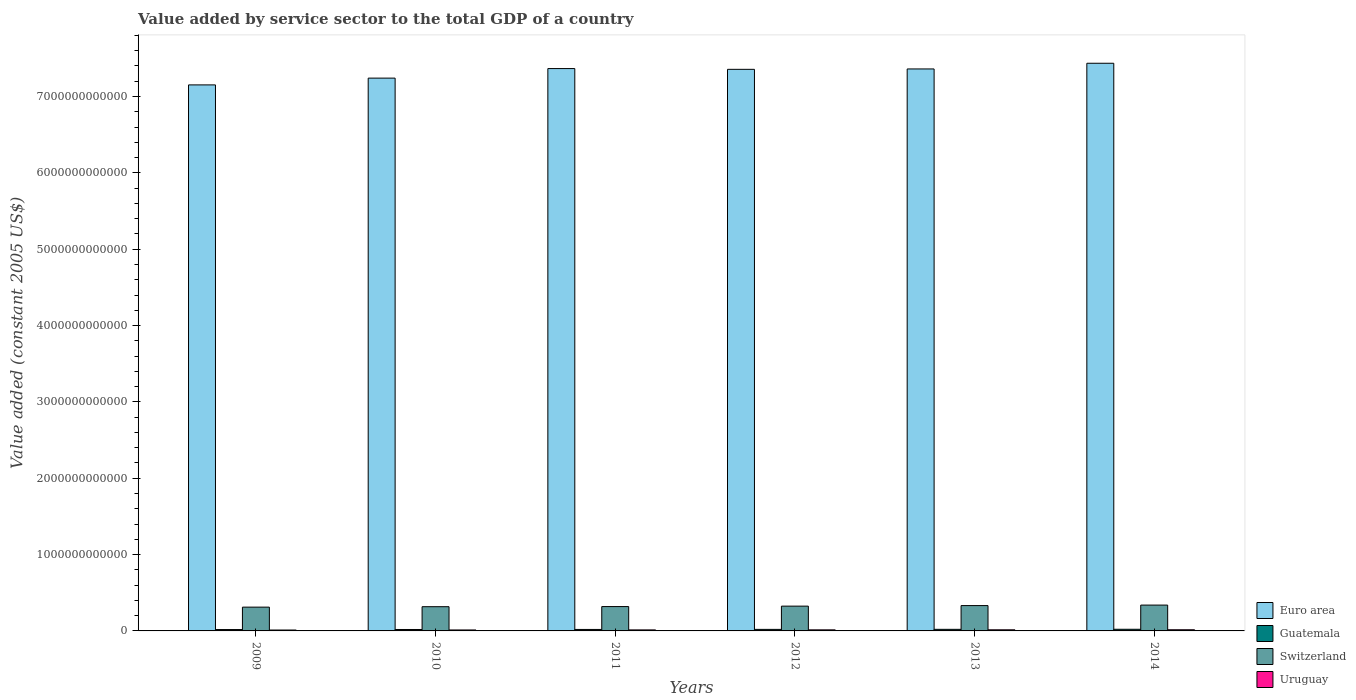Are the number of bars per tick equal to the number of legend labels?
Offer a terse response. Yes. Are the number of bars on each tick of the X-axis equal?
Provide a short and direct response. Yes. How many bars are there on the 5th tick from the left?
Your response must be concise. 4. What is the label of the 2nd group of bars from the left?
Keep it short and to the point. 2010. In how many cases, is the number of bars for a given year not equal to the number of legend labels?
Provide a short and direct response. 0. What is the value added by service sector in Euro area in 2012?
Offer a terse response. 7.36e+12. Across all years, what is the maximum value added by service sector in Guatemala?
Your answer should be compact. 2.15e+1. Across all years, what is the minimum value added by service sector in Euro area?
Provide a short and direct response. 7.15e+12. In which year was the value added by service sector in Uruguay maximum?
Give a very brief answer. 2014. In which year was the value added by service sector in Euro area minimum?
Ensure brevity in your answer.  2009. What is the total value added by service sector in Uruguay in the graph?
Ensure brevity in your answer.  8.18e+1. What is the difference between the value added by service sector in Uruguay in 2011 and that in 2012?
Offer a terse response. -6.60e+08. What is the difference between the value added by service sector in Euro area in 2012 and the value added by service sector in Guatemala in 2013?
Keep it short and to the point. 7.34e+12. What is the average value added by service sector in Euro area per year?
Offer a terse response. 7.32e+12. In the year 2013, what is the difference between the value added by service sector in Uruguay and value added by service sector in Guatemala?
Your answer should be compact. -6.11e+09. What is the ratio of the value added by service sector in Euro area in 2010 to that in 2011?
Your response must be concise. 0.98. Is the value added by service sector in Guatemala in 2012 less than that in 2013?
Provide a succinct answer. Yes. Is the difference between the value added by service sector in Uruguay in 2013 and 2014 greater than the difference between the value added by service sector in Guatemala in 2013 and 2014?
Your answer should be compact. Yes. What is the difference between the highest and the second highest value added by service sector in Euro area?
Provide a short and direct response. 6.95e+1. What is the difference between the highest and the lowest value added by service sector in Switzerland?
Offer a very short reply. 2.67e+1. In how many years, is the value added by service sector in Uruguay greater than the average value added by service sector in Uruguay taken over all years?
Give a very brief answer. 3. Is the sum of the value added by service sector in Euro area in 2010 and 2011 greater than the maximum value added by service sector in Switzerland across all years?
Offer a terse response. Yes. What does the 2nd bar from the left in 2014 represents?
Your answer should be very brief. Guatemala. What does the 2nd bar from the right in 2009 represents?
Ensure brevity in your answer.  Switzerland. What is the difference between two consecutive major ticks on the Y-axis?
Give a very brief answer. 1.00e+12. Are the values on the major ticks of Y-axis written in scientific E-notation?
Give a very brief answer. No. Does the graph contain any zero values?
Make the answer very short. No. Does the graph contain grids?
Make the answer very short. No. Where does the legend appear in the graph?
Your answer should be very brief. Bottom right. How many legend labels are there?
Your response must be concise. 4. How are the legend labels stacked?
Offer a very short reply. Vertical. What is the title of the graph?
Your answer should be very brief. Value added by service sector to the total GDP of a country. What is the label or title of the Y-axis?
Your answer should be very brief. Value added (constant 2005 US$). What is the Value added (constant 2005 US$) in Euro area in 2009?
Give a very brief answer. 7.15e+12. What is the Value added (constant 2005 US$) in Guatemala in 2009?
Your response must be concise. 1.79e+1. What is the Value added (constant 2005 US$) of Switzerland in 2009?
Your response must be concise. 3.12e+11. What is the Value added (constant 2005 US$) in Uruguay in 2009?
Make the answer very short. 1.18e+1. What is the Value added (constant 2005 US$) in Euro area in 2010?
Your answer should be very brief. 7.24e+12. What is the Value added (constant 2005 US$) of Guatemala in 2010?
Ensure brevity in your answer.  1.87e+1. What is the Value added (constant 2005 US$) in Switzerland in 2010?
Provide a short and direct response. 3.17e+11. What is the Value added (constant 2005 US$) in Uruguay in 2010?
Your answer should be very brief. 1.27e+1. What is the Value added (constant 2005 US$) in Euro area in 2011?
Give a very brief answer. 7.37e+12. What is the Value added (constant 2005 US$) in Guatemala in 2011?
Your answer should be compact. 1.94e+1. What is the Value added (constant 2005 US$) in Switzerland in 2011?
Offer a very short reply. 3.19e+11. What is the Value added (constant 2005 US$) of Uruguay in 2011?
Your answer should be very brief. 1.34e+1. What is the Value added (constant 2005 US$) of Euro area in 2012?
Make the answer very short. 7.36e+12. What is the Value added (constant 2005 US$) of Guatemala in 2012?
Ensure brevity in your answer.  2.01e+1. What is the Value added (constant 2005 US$) of Switzerland in 2012?
Your answer should be very brief. 3.25e+11. What is the Value added (constant 2005 US$) in Uruguay in 2012?
Your answer should be compact. 1.40e+1. What is the Value added (constant 2005 US$) in Euro area in 2013?
Make the answer very short. 7.36e+12. What is the Value added (constant 2005 US$) of Guatemala in 2013?
Offer a very short reply. 2.08e+1. What is the Value added (constant 2005 US$) in Switzerland in 2013?
Offer a very short reply. 3.32e+11. What is the Value added (constant 2005 US$) of Uruguay in 2013?
Ensure brevity in your answer.  1.47e+1. What is the Value added (constant 2005 US$) of Euro area in 2014?
Your answer should be very brief. 7.44e+12. What is the Value added (constant 2005 US$) in Guatemala in 2014?
Your answer should be very brief. 2.15e+1. What is the Value added (constant 2005 US$) of Switzerland in 2014?
Give a very brief answer. 3.38e+11. What is the Value added (constant 2005 US$) in Uruguay in 2014?
Offer a terse response. 1.52e+1. Across all years, what is the maximum Value added (constant 2005 US$) in Euro area?
Your answer should be compact. 7.44e+12. Across all years, what is the maximum Value added (constant 2005 US$) in Guatemala?
Provide a short and direct response. 2.15e+1. Across all years, what is the maximum Value added (constant 2005 US$) of Switzerland?
Provide a short and direct response. 3.38e+11. Across all years, what is the maximum Value added (constant 2005 US$) in Uruguay?
Ensure brevity in your answer.  1.52e+1. Across all years, what is the minimum Value added (constant 2005 US$) in Euro area?
Make the answer very short. 7.15e+12. Across all years, what is the minimum Value added (constant 2005 US$) of Guatemala?
Keep it short and to the point. 1.79e+1. Across all years, what is the minimum Value added (constant 2005 US$) in Switzerland?
Your answer should be very brief. 3.12e+11. Across all years, what is the minimum Value added (constant 2005 US$) of Uruguay?
Keep it short and to the point. 1.18e+1. What is the total Value added (constant 2005 US$) of Euro area in the graph?
Make the answer very short. 4.39e+13. What is the total Value added (constant 2005 US$) in Guatemala in the graph?
Make the answer very short. 1.18e+11. What is the total Value added (constant 2005 US$) in Switzerland in the graph?
Provide a succinct answer. 1.94e+12. What is the total Value added (constant 2005 US$) of Uruguay in the graph?
Provide a succinct answer. 8.18e+1. What is the difference between the Value added (constant 2005 US$) of Euro area in 2009 and that in 2010?
Ensure brevity in your answer.  -8.87e+1. What is the difference between the Value added (constant 2005 US$) of Guatemala in 2009 and that in 2010?
Offer a very short reply. -7.46e+08. What is the difference between the Value added (constant 2005 US$) of Switzerland in 2009 and that in 2010?
Offer a very short reply. -5.63e+09. What is the difference between the Value added (constant 2005 US$) of Uruguay in 2009 and that in 2010?
Make the answer very short. -8.67e+08. What is the difference between the Value added (constant 2005 US$) in Euro area in 2009 and that in 2011?
Your answer should be compact. -2.14e+11. What is the difference between the Value added (constant 2005 US$) in Guatemala in 2009 and that in 2011?
Keep it short and to the point. -1.48e+09. What is the difference between the Value added (constant 2005 US$) of Switzerland in 2009 and that in 2011?
Offer a terse response. -7.32e+09. What is the difference between the Value added (constant 2005 US$) of Uruguay in 2009 and that in 2011?
Make the answer very short. -1.57e+09. What is the difference between the Value added (constant 2005 US$) in Euro area in 2009 and that in 2012?
Your answer should be very brief. -2.04e+11. What is the difference between the Value added (constant 2005 US$) in Guatemala in 2009 and that in 2012?
Keep it short and to the point. -2.18e+09. What is the difference between the Value added (constant 2005 US$) in Switzerland in 2009 and that in 2012?
Give a very brief answer. -1.30e+1. What is the difference between the Value added (constant 2005 US$) in Uruguay in 2009 and that in 2012?
Your answer should be very brief. -2.23e+09. What is the difference between the Value added (constant 2005 US$) of Euro area in 2009 and that in 2013?
Provide a succinct answer. -2.09e+11. What is the difference between the Value added (constant 2005 US$) of Guatemala in 2009 and that in 2013?
Provide a short and direct response. -2.91e+09. What is the difference between the Value added (constant 2005 US$) of Switzerland in 2009 and that in 2013?
Your response must be concise. -2.03e+1. What is the difference between the Value added (constant 2005 US$) of Uruguay in 2009 and that in 2013?
Make the answer very short. -2.91e+09. What is the difference between the Value added (constant 2005 US$) of Euro area in 2009 and that in 2014?
Give a very brief answer. -2.83e+11. What is the difference between the Value added (constant 2005 US$) in Guatemala in 2009 and that in 2014?
Make the answer very short. -3.61e+09. What is the difference between the Value added (constant 2005 US$) in Switzerland in 2009 and that in 2014?
Keep it short and to the point. -2.67e+1. What is the difference between the Value added (constant 2005 US$) in Uruguay in 2009 and that in 2014?
Offer a terse response. -3.37e+09. What is the difference between the Value added (constant 2005 US$) of Euro area in 2010 and that in 2011?
Give a very brief answer. -1.25e+11. What is the difference between the Value added (constant 2005 US$) of Guatemala in 2010 and that in 2011?
Keep it short and to the point. -7.34e+08. What is the difference between the Value added (constant 2005 US$) of Switzerland in 2010 and that in 2011?
Make the answer very short. -1.70e+09. What is the difference between the Value added (constant 2005 US$) in Uruguay in 2010 and that in 2011?
Offer a very short reply. -7.06e+08. What is the difference between the Value added (constant 2005 US$) in Euro area in 2010 and that in 2012?
Ensure brevity in your answer.  -1.15e+11. What is the difference between the Value added (constant 2005 US$) of Guatemala in 2010 and that in 2012?
Keep it short and to the point. -1.44e+09. What is the difference between the Value added (constant 2005 US$) in Switzerland in 2010 and that in 2012?
Provide a short and direct response. -7.38e+09. What is the difference between the Value added (constant 2005 US$) in Uruguay in 2010 and that in 2012?
Ensure brevity in your answer.  -1.37e+09. What is the difference between the Value added (constant 2005 US$) of Euro area in 2010 and that in 2013?
Offer a terse response. -1.20e+11. What is the difference between the Value added (constant 2005 US$) of Guatemala in 2010 and that in 2013?
Offer a terse response. -2.16e+09. What is the difference between the Value added (constant 2005 US$) of Switzerland in 2010 and that in 2013?
Provide a short and direct response. -1.46e+1. What is the difference between the Value added (constant 2005 US$) of Uruguay in 2010 and that in 2013?
Your answer should be compact. -2.04e+09. What is the difference between the Value added (constant 2005 US$) of Euro area in 2010 and that in 2014?
Your answer should be very brief. -1.95e+11. What is the difference between the Value added (constant 2005 US$) in Guatemala in 2010 and that in 2014?
Your answer should be very brief. -2.86e+09. What is the difference between the Value added (constant 2005 US$) in Switzerland in 2010 and that in 2014?
Give a very brief answer. -2.11e+1. What is the difference between the Value added (constant 2005 US$) in Uruguay in 2010 and that in 2014?
Make the answer very short. -2.50e+09. What is the difference between the Value added (constant 2005 US$) of Euro area in 2011 and that in 2012?
Your answer should be very brief. 1.02e+1. What is the difference between the Value added (constant 2005 US$) in Guatemala in 2011 and that in 2012?
Offer a very short reply. -7.04e+08. What is the difference between the Value added (constant 2005 US$) in Switzerland in 2011 and that in 2012?
Ensure brevity in your answer.  -5.69e+09. What is the difference between the Value added (constant 2005 US$) of Uruguay in 2011 and that in 2012?
Give a very brief answer. -6.60e+08. What is the difference between the Value added (constant 2005 US$) of Euro area in 2011 and that in 2013?
Your answer should be very brief. 5.09e+09. What is the difference between the Value added (constant 2005 US$) in Guatemala in 2011 and that in 2013?
Provide a succinct answer. -1.43e+09. What is the difference between the Value added (constant 2005 US$) of Switzerland in 2011 and that in 2013?
Offer a very short reply. -1.30e+1. What is the difference between the Value added (constant 2005 US$) of Uruguay in 2011 and that in 2013?
Ensure brevity in your answer.  -1.33e+09. What is the difference between the Value added (constant 2005 US$) of Euro area in 2011 and that in 2014?
Ensure brevity in your answer.  -6.95e+1. What is the difference between the Value added (constant 2005 US$) in Guatemala in 2011 and that in 2014?
Your answer should be very brief. -2.13e+09. What is the difference between the Value added (constant 2005 US$) of Switzerland in 2011 and that in 2014?
Offer a very short reply. -1.94e+1. What is the difference between the Value added (constant 2005 US$) of Uruguay in 2011 and that in 2014?
Your answer should be very brief. -1.79e+09. What is the difference between the Value added (constant 2005 US$) in Euro area in 2012 and that in 2013?
Give a very brief answer. -5.07e+09. What is the difference between the Value added (constant 2005 US$) in Guatemala in 2012 and that in 2013?
Make the answer very short. -7.28e+08. What is the difference between the Value added (constant 2005 US$) of Switzerland in 2012 and that in 2013?
Offer a terse response. -7.27e+09. What is the difference between the Value added (constant 2005 US$) of Uruguay in 2012 and that in 2013?
Give a very brief answer. -6.74e+08. What is the difference between the Value added (constant 2005 US$) of Euro area in 2012 and that in 2014?
Make the answer very short. -7.97e+1. What is the difference between the Value added (constant 2005 US$) of Guatemala in 2012 and that in 2014?
Offer a very short reply. -1.42e+09. What is the difference between the Value added (constant 2005 US$) of Switzerland in 2012 and that in 2014?
Offer a very short reply. -1.37e+1. What is the difference between the Value added (constant 2005 US$) in Uruguay in 2012 and that in 2014?
Give a very brief answer. -1.13e+09. What is the difference between the Value added (constant 2005 US$) in Euro area in 2013 and that in 2014?
Provide a succinct answer. -7.46e+1. What is the difference between the Value added (constant 2005 US$) in Guatemala in 2013 and that in 2014?
Provide a succinct answer. -6.95e+08. What is the difference between the Value added (constant 2005 US$) of Switzerland in 2013 and that in 2014?
Keep it short and to the point. -6.40e+09. What is the difference between the Value added (constant 2005 US$) in Uruguay in 2013 and that in 2014?
Provide a short and direct response. -4.60e+08. What is the difference between the Value added (constant 2005 US$) in Euro area in 2009 and the Value added (constant 2005 US$) in Guatemala in 2010?
Make the answer very short. 7.13e+12. What is the difference between the Value added (constant 2005 US$) of Euro area in 2009 and the Value added (constant 2005 US$) of Switzerland in 2010?
Offer a very short reply. 6.84e+12. What is the difference between the Value added (constant 2005 US$) in Euro area in 2009 and the Value added (constant 2005 US$) in Uruguay in 2010?
Make the answer very short. 7.14e+12. What is the difference between the Value added (constant 2005 US$) in Guatemala in 2009 and the Value added (constant 2005 US$) in Switzerland in 2010?
Your response must be concise. -2.99e+11. What is the difference between the Value added (constant 2005 US$) in Guatemala in 2009 and the Value added (constant 2005 US$) in Uruguay in 2010?
Make the answer very short. 5.24e+09. What is the difference between the Value added (constant 2005 US$) in Switzerland in 2009 and the Value added (constant 2005 US$) in Uruguay in 2010?
Ensure brevity in your answer.  2.99e+11. What is the difference between the Value added (constant 2005 US$) in Euro area in 2009 and the Value added (constant 2005 US$) in Guatemala in 2011?
Your answer should be very brief. 7.13e+12. What is the difference between the Value added (constant 2005 US$) in Euro area in 2009 and the Value added (constant 2005 US$) in Switzerland in 2011?
Your answer should be very brief. 6.83e+12. What is the difference between the Value added (constant 2005 US$) of Euro area in 2009 and the Value added (constant 2005 US$) of Uruguay in 2011?
Your response must be concise. 7.14e+12. What is the difference between the Value added (constant 2005 US$) in Guatemala in 2009 and the Value added (constant 2005 US$) in Switzerland in 2011?
Provide a succinct answer. -3.01e+11. What is the difference between the Value added (constant 2005 US$) of Guatemala in 2009 and the Value added (constant 2005 US$) of Uruguay in 2011?
Provide a succinct answer. 4.53e+09. What is the difference between the Value added (constant 2005 US$) of Switzerland in 2009 and the Value added (constant 2005 US$) of Uruguay in 2011?
Your answer should be very brief. 2.98e+11. What is the difference between the Value added (constant 2005 US$) of Euro area in 2009 and the Value added (constant 2005 US$) of Guatemala in 2012?
Give a very brief answer. 7.13e+12. What is the difference between the Value added (constant 2005 US$) in Euro area in 2009 and the Value added (constant 2005 US$) in Switzerland in 2012?
Ensure brevity in your answer.  6.83e+12. What is the difference between the Value added (constant 2005 US$) of Euro area in 2009 and the Value added (constant 2005 US$) of Uruguay in 2012?
Offer a terse response. 7.14e+12. What is the difference between the Value added (constant 2005 US$) of Guatemala in 2009 and the Value added (constant 2005 US$) of Switzerland in 2012?
Provide a succinct answer. -3.07e+11. What is the difference between the Value added (constant 2005 US$) in Guatemala in 2009 and the Value added (constant 2005 US$) in Uruguay in 2012?
Your answer should be compact. 3.87e+09. What is the difference between the Value added (constant 2005 US$) in Switzerland in 2009 and the Value added (constant 2005 US$) in Uruguay in 2012?
Give a very brief answer. 2.98e+11. What is the difference between the Value added (constant 2005 US$) of Euro area in 2009 and the Value added (constant 2005 US$) of Guatemala in 2013?
Offer a terse response. 7.13e+12. What is the difference between the Value added (constant 2005 US$) in Euro area in 2009 and the Value added (constant 2005 US$) in Switzerland in 2013?
Give a very brief answer. 6.82e+12. What is the difference between the Value added (constant 2005 US$) in Euro area in 2009 and the Value added (constant 2005 US$) in Uruguay in 2013?
Give a very brief answer. 7.14e+12. What is the difference between the Value added (constant 2005 US$) of Guatemala in 2009 and the Value added (constant 2005 US$) of Switzerland in 2013?
Give a very brief answer. -3.14e+11. What is the difference between the Value added (constant 2005 US$) in Guatemala in 2009 and the Value added (constant 2005 US$) in Uruguay in 2013?
Your answer should be compact. 3.20e+09. What is the difference between the Value added (constant 2005 US$) in Switzerland in 2009 and the Value added (constant 2005 US$) in Uruguay in 2013?
Provide a succinct answer. 2.97e+11. What is the difference between the Value added (constant 2005 US$) in Euro area in 2009 and the Value added (constant 2005 US$) in Guatemala in 2014?
Your response must be concise. 7.13e+12. What is the difference between the Value added (constant 2005 US$) in Euro area in 2009 and the Value added (constant 2005 US$) in Switzerland in 2014?
Offer a terse response. 6.81e+12. What is the difference between the Value added (constant 2005 US$) of Euro area in 2009 and the Value added (constant 2005 US$) of Uruguay in 2014?
Offer a very short reply. 7.14e+12. What is the difference between the Value added (constant 2005 US$) in Guatemala in 2009 and the Value added (constant 2005 US$) in Switzerland in 2014?
Give a very brief answer. -3.20e+11. What is the difference between the Value added (constant 2005 US$) in Guatemala in 2009 and the Value added (constant 2005 US$) in Uruguay in 2014?
Provide a succinct answer. 2.74e+09. What is the difference between the Value added (constant 2005 US$) of Switzerland in 2009 and the Value added (constant 2005 US$) of Uruguay in 2014?
Provide a succinct answer. 2.96e+11. What is the difference between the Value added (constant 2005 US$) in Euro area in 2010 and the Value added (constant 2005 US$) in Guatemala in 2011?
Keep it short and to the point. 7.22e+12. What is the difference between the Value added (constant 2005 US$) in Euro area in 2010 and the Value added (constant 2005 US$) in Switzerland in 2011?
Give a very brief answer. 6.92e+12. What is the difference between the Value added (constant 2005 US$) in Euro area in 2010 and the Value added (constant 2005 US$) in Uruguay in 2011?
Keep it short and to the point. 7.23e+12. What is the difference between the Value added (constant 2005 US$) in Guatemala in 2010 and the Value added (constant 2005 US$) in Switzerland in 2011?
Ensure brevity in your answer.  -3.00e+11. What is the difference between the Value added (constant 2005 US$) in Guatemala in 2010 and the Value added (constant 2005 US$) in Uruguay in 2011?
Give a very brief answer. 5.28e+09. What is the difference between the Value added (constant 2005 US$) in Switzerland in 2010 and the Value added (constant 2005 US$) in Uruguay in 2011?
Your answer should be very brief. 3.04e+11. What is the difference between the Value added (constant 2005 US$) of Euro area in 2010 and the Value added (constant 2005 US$) of Guatemala in 2012?
Keep it short and to the point. 7.22e+12. What is the difference between the Value added (constant 2005 US$) of Euro area in 2010 and the Value added (constant 2005 US$) of Switzerland in 2012?
Make the answer very short. 6.92e+12. What is the difference between the Value added (constant 2005 US$) of Euro area in 2010 and the Value added (constant 2005 US$) of Uruguay in 2012?
Your answer should be compact. 7.23e+12. What is the difference between the Value added (constant 2005 US$) of Guatemala in 2010 and the Value added (constant 2005 US$) of Switzerland in 2012?
Make the answer very short. -3.06e+11. What is the difference between the Value added (constant 2005 US$) in Guatemala in 2010 and the Value added (constant 2005 US$) in Uruguay in 2012?
Give a very brief answer. 4.62e+09. What is the difference between the Value added (constant 2005 US$) in Switzerland in 2010 and the Value added (constant 2005 US$) in Uruguay in 2012?
Your answer should be very brief. 3.03e+11. What is the difference between the Value added (constant 2005 US$) of Euro area in 2010 and the Value added (constant 2005 US$) of Guatemala in 2013?
Keep it short and to the point. 7.22e+12. What is the difference between the Value added (constant 2005 US$) of Euro area in 2010 and the Value added (constant 2005 US$) of Switzerland in 2013?
Your answer should be compact. 6.91e+12. What is the difference between the Value added (constant 2005 US$) of Euro area in 2010 and the Value added (constant 2005 US$) of Uruguay in 2013?
Make the answer very short. 7.23e+12. What is the difference between the Value added (constant 2005 US$) of Guatemala in 2010 and the Value added (constant 2005 US$) of Switzerland in 2013?
Provide a succinct answer. -3.13e+11. What is the difference between the Value added (constant 2005 US$) of Guatemala in 2010 and the Value added (constant 2005 US$) of Uruguay in 2013?
Provide a succinct answer. 3.94e+09. What is the difference between the Value added (constant 2005 US$) in Switzerland in 2010 and the Value added (constant 2005 US$) in Uruguay in 2013?
Provide a succinct answer. 3.03e+11. What is the difference between the Value added (constant 2005 US$) in Euro area in 2010 and the Value added (constant 2005 US$) in Guatemala in 2014?
Your answer should be very brief. 7.22e+12. What is the difference between the Value added (constant 2005 US$) of Euro area in 2010 and the Value added (constant 2005 US$) of Switzerland in 2014?
Ensure brevity in your answer.  6.90e+12. What is the difference between the Value added (constant 2005 US$) of Euro area in 2010 and the Value added (constant 2005 US$) of Uruguay in 2014?
Your answer should be very brief. 7.23e+12. What is the difference between the Value added (constant 2005 US$) of Guatemala in 2010 and the Value added (constant 2005 US$) of Switzerland in 2014?
Ensure brevity in your answer.  -3.20e+11. What is the difference between the Value added (constant 2005 US$) in Guatemala in 2010 and the Value added (constant 2005 US$) in Uruguay in 2014?
Make the answer very short. 3.48e+09. What is the difference between the Value added (constant 2005 US$) of Switzerland in 2010 and the Value added (constant 2005 US$) of Uruguay in 2014?
Your answer should be very brief. 3.02e+11. What is the difference between the Value added (constant 2005 US$) of Euro area in 2011 and the Value added (constant 2005 US$) of Guatemala in 2012?
Your answer should be compact. 7.35e+12. What is the difference between the Value added (constant 2005 US$) in Euro area in 2011 and the Value added (constant 2005 US$) in Switzerland in 2012?
Offer a very short reply. 7.04e+12. What is the difference between the Value added (constant 2005 US$) in Euro area in 2011 and the Value added (constant 2005 US$) in Uruguay in 2012?
Provide a short and direct response. 7.35e+12. What is the difference between the Value added (constant 2005 US$) of Guatemala in 2011 and the Value added (constant 2005 US$) of Switzerland in 2012?
Your answer should be very brief. -3.05e+11. What is the difference between the Value added (constant 2005 US$) in Guatemala in 2011 and the Value added (constant 2005 US$) in Uruguay in 2012?
Offer a terse response. 5.35e+09. What is the difference between the Value added (constant 2005 US$) of Switzerland in 2011 and the Value added (constant 2005 US$) of Uruguay in 2012?
Your answer should be compact. 3.05e+11. What is the difference between the Value added (constant 2005 US$) in Euro area in 2011 and the Value added (constant 2005 US$) in Guatemala in 2013?
Keep it short and to the point. 7.35e+12. What is the difference between the Value added (constant 2005 US$) in Euro area in 2011 and the Value added (constant 2005 US$) in Switzerland in 2013?
Ensure brevity in your answer.  7.03e+12. What is the difference between the Value added (constant 2005 US$) of Euro area in 2011 and the Value added (constant 2005 US$) of Uruguay in 2013?
Your answer should be very brief. 7.35e+12. What is the difference between the Value added (constant 2005 US$) of Guatemala in 2011 and the Value added (constant 2005 US$) of Switzerland in 2013?
Provide a succinct answer. -3.13e+11. What is the difference between the Value added (constant 2005 US$) of Guatemala in 2011 and the Value added (constant 2005 US$) of Uruguay in 2013?
Your response must be concise. 4.68e+09. What is the difference between the Value added (constant 2005 US$) of Switzerland in 2011 and the Value added (constant 2005 US$) of Uruguay in 2013?
Provide a succinct answer. 3.04e+11. What is the difference between the Value added (constant 2005 US$) in Euro area in 2011 and the Value added (constant 2005 US$) in Guatemala in 2014?
Offer a very short reply. 7.34e+12. What is the difference between the Value added (constant 2005 US$) of Euro area in 2011 and the Value added (constant 2005 US$) of Switzerland in 2014?
Your answer should be very brief. 7.03e+12. What is the difference between the Value added (constant 2005 US$) in Euro area in 2011 and the Value added (constant 2005 US$) in Uruguay in 2014?
Ensure brevity in your answer.  7.35e+12. What is the difference between the Value added (constant 2005 US$) in Guatemala in 2011 and the Value added (constant 2005 US$) in Switzerland in 2014?
Offer a very short reply. -3.19e+11. What is the difference between the Value added (constant 2005 US$) in Guatemala in 2011 and the Value added (constant 2005 US$) in Uruguay in 2014?
Give a very brief answer. 4.22e+09. What is the difference between the Value added (constant 2005 US$) of Switzerland in 2011 and the Value added (constant 2005 US$) of Uruguay in 2014?
Your answer should be very brief. 3.04e+11. What is the difference between the Value added (constant 2005 US$) in Euro area in 2012 and the Value added (constant 2005 US$) in Guatemala in 2013?
Provide a succinct answer. 7.34e+12. What is the difference between the Value added (constant 2005 US$) in Euro area in 2012 and the Value added (constant 2005 US$) in Switzerland in 2013?
Provide a succinct answer. 7.02e+12. What is the difference between the Value added (constant 2005 US$) of Euro area in 2012 and the Value added (constant 2005 US$) of Uruguay in 2013?
Make the answer very short. 7.34e+12. What is the difference between the Value added (constant 2005 US$) in Guatemala in 2012 and the Value added (constant 2005 US$) in Switzerland in 2013?
Your answer should be very brief. -3.12e+11. What is the difference between the Value added (constant 2005 US$) in Guatemala in 2012 and the Value added (constant 2005 US$) in Uruguay in 2013?
Give a very brief answer. 5.38e+09. What is the difference between the Value added (constant 2005 US$) in Switzerland in 2012 and the Value added (constant 2005 US$) in Uruguay in 2013?
Offer a terse response. 3.10e+11. What is the difference between the Value added (constant 2005 US$) of Euro area in 2012 and the Value added (constant 2005 US$) of Guatemala in 2014?
Make the answer very short. 7.33e+12. What is the difference between the Value added (constant 2005 US$) of Euro area in 2012 and the Value added (constant 2005 US$) of Switzerland in 2014?
Make the answer very short. 7.02e+12. What is the difference between the Value added (constant 2005 US$) in Euro area in 2012 and the Value added (constant 2005 US$) in Uruguay in 2014?
Provide a short and direct response. 7.34e+12. What is the difference between the Value added (constant 2005 US$) in Guatemala in 2012 and the Value added (constant 2005 US$) in Switzerland in 2014?
Keep it short and to the point. -3.18e+11. What is the difference between the Value added (constant 2005 US$) in Guatemala in 2012 and the Value added (constant 2005 US$) in Uruguay in 2014?
Your answer should be very brief. 4.92e+09. What is the difference between the Value added (constant 2005 US$) of Switzerland in 2012 and the Value added (constant 2005 US$) of Uruguay in 2014?
Offer a terse response. 3.09e+11. What is the difference between the Value added (constant 2005 US$) in Euro area in 2013 and the Value added (constant 2005 US$) in Guatemala in 2014?
Your response must be concise. 7.34e+12. What is the difference between the Value added (constant 2005 US$) in Euro area in 2013 and the Value added (constant 2005 US$) in Switzerland in 2014?
Your answer should be compact. 7.02e+12. What is the difference between the Value added (constant 2005 US$) of Euro area in 2013 and the Value added (constant 2005 US$) of Uruguay in 2014?
Your response must be concise. 7.35e+12. What is the difference between the Value added (constant 2005 US$) of Guatemala in 2013 and the Value added (constant 2005 US$) of Switzerland in 2014?
Offer a terse response. -3.18e+11. What is the difference between the Value added (constant 2005 US$) of Guatemala in 2013 and the Value added (constant 2005 US$) of Uruguay in 2014?
Offer a terse response. 5.65e+09. What is the difference between the Value added (constant 2005 US$) of Switzerland in 2013 and the Value added (constant 2005 US$) of Uruguay in 2014?
Make the answer very short. 3.17e+11. What is the average Value added (constant 2005 US$) of Euro area per year?
Offer a very short reply. 7.32e+12. What is the average Value added (constant 2005 US$) in Guatemala per year?
Your answer should be compact. 1.97e+1. What is the average Value added (constant 2005 US$) of Switzerland per year?
Your response must be concise. 3.24e+11. What is the average Value added (constant 2005 US$) of Uruguay per year?
Provide a succinct answer. 1.36e+1. In the year 2009, what is the difference between the Value added (constant 2005 US$) of Euro area and Value added (constant 2005 US$) of Guatemala?
Your answer should be compact. 7.13e+12. In the year 2009, what is the difference between the Value added (constant 2005 US$) in Euro area and Value added (constant 2005 US$) in Switzerland?
Offer a terse response. 6.84e+12. In the year 2009, what is the difference between the Value added (constant 2005 US$) in Euro area and Value added (constant 2005 US$) in Uruguay?
Make the answer very short. 7.14e+12. In the year 2009, what is the difference between the Value added (constant 2005 US$) of Guatemala and Value added (constant 2005 US$) of Switzerland?
Ensure brevity in your answer.  -2.94e+11. In the year 2009, what is the difference between the Value added (constant 2005 US$) in Guatemala and Value added (constant 2005 US$) in Uruguay?
Your answer should be very brief. 6.10e+09. In the year 2009, what is the difference between the Value added (constant 2005 US$) of Switzerland and Value added (constant 2005 US$) of Uruguay?
Your response must be concise. 3.00e+11. In the year 2010, what is the difference between the Value added (constant 2005 US$) in Euro area and Value added (constant 2005 US$) in Guatemala?
Your response must be concise. 7.22e+12. In the year 2010, what is the difference between the Value added (constant 2005 US$) of Euro area and Value added (constant 2005 US$) of Switzerland?
Your answer should be compact. 6.92e+12. In the year 2010, what is the difference between the Value added (constant 2005 US$) of Euro area and Value added (constant 2005 US$) of Uruguay?
Ensure brevity in your answer.  7.23e+12. In the year 2010, what is the difference between the Value added (constant 2005 US$) of Guatemala and Value added (constant 2005 US$) of Switzerland?
Your response must be concise. -2.99e+11. In the year 2010, what is the difference between the Value added (constant 2005 US$) of Guatemala and Value added (constant 2005 US$) of Uruguay?
Keep it short and to the point. 5.98e+09. In the year 2010, what is the difference between the Value added (constant 2005 US$) in Switzerland and Value added (constant 2005 US$) in Uruguay?
Your response must be concise. 3.05e+11. In the year 2011, what is the difference between the Value added (constant 2005 US$) in Euro area and Value added (constant 2005 US$) in Guatemala?
Give a very brief answer. 7.35e+12. In the year 2011, what is the difference between the Value added (constant 2005 US$) of Euro area and Value added (constant 2005 US$) of Switzerland?
Ensure brevity in your answer.  7.05e+12. In the year 2011, what is the difference between the Value added (constant 2005 US$) of Euro area and Value added (constant 2005 US$) of Uruguay?
Offer a terse response. 7.35e+12. In the year 2011, what is the difference between the Value added (constant 2005 US$) in Guatemala and Value added (constant 2005 US$) in Switzerland?
Offer a terse response. -3.00e+11. In the year 2011, what is the difference between the Value added (constant 2005 US$) of Guatemala and Value added (constant 2005 US$) of Uruguay?
Make the answer very short. 6.01e+09. In the year 2011, what is the difference between the Value added (constant 2005 US$) of Switzerland and Value added (constant 2005 US$) of Uruguay?
Make the answer very short. 3.06e+11. In the year 2012, what is the difference between the Value added (constant 2005 US$) of Euro area and Value added (constant 2005 US$) of Guatemala?
Your response must be concise. 7.34e+12. In the year 2012, what is the difference between the Value added (constant 2005 US$) of Euro area and Value added (constant 2005 US$) of Switzerland?
Provide a succinct answer. 7.03e+12. In the year 2012, what is the difference between the Value added (constant 2005 US$) in Euro area and Value added (constant 2005 US$) in Uruguay?
Ensure brevity in your answer.  7.34e+12. In the year 2012, what is the difference between the Value added (constant 2005 US$) of Guatemala and Value added (constant 2005 US$) of Switzerland?
Provide a short and direct response. -3.05e+11. In the year 2012, what is the difference between the Value added (constant 2005 US$) in Guatemala and Value added (constant 2005 US$) in Uruguay?
Your answer should be very brief. 6.05e+09. In the year 2012, what is the difference between the Value added (constant 2005 US$) in Switzerland and Value added (constant 2005 US$) in Uruguay?
Your answer should be compact. 3.11e+11. In the year 2013, what is the difference between the Value added (constant 2005 US$) of Euro area and Value added (constant 2005 US$) of Guatemala?
Offer a terse response. 7.34e+12. In the year 2013, what is the difference between the Value added (constant 2005 US$) in Euro area and Value added (constant 2005 US$) in Switzerland?
Your answer should be compact. 7.03e+12. In the year 2013, what is the difference between the Value added (constant 2005 US$) of Euro area and Value added (constant 2005 US$) of Uruguay?
Give a very brief answer. 7.35e+12. In the year 2013, what is the difference between the Value added (constant 2005 US$) in Guatemala and Value added (constant 2005 US$) in Switzerland?
Make the answer very short. -3.11e+11. In the year 2013, what is the difference between the Value added (constant 2005 US$) of Guatemala and Value added (constant 2005 US$) of Uruguay?
Your response must be concise. 6.11e+09. In the year 2013, what is the difference between the Value added (constant 2005 US$) in Switzerland and Value added (constant 2005 US$) in Uruguay?
Your response must be concise. 3.17e+11. In the year 2014, what is the difference between the Value added (constant 2005 US$) of Euro area and Value added (constant 2005 US$) of Guatemala?
Provide a short and direct response. 7.41e+12. In the year 2014, what is the difference between the Value added (constant 2005 US$) in Euro area and Value added (constant 2005 US$) in Switzerland?
Your answer should be compact. 7.10e+12. In the year 2014, what is the difference between the Value added (constant 2005 US$) in Euro area and Value added (constant 2005 US$) in Uruguay?
Keep it short and to the point. 7.42e+12. In the year 2014, what is the difference between the Value added (constant 2005 US$) in Guatemala and Value added (constant 2005 US$) in Switzerland?
Offer a terse response. -3.17e+11. In the year 2014, what is the difference between the Value added (constant 2005 US$) in Guatemala and Value added (constant 2005 US$) in Uruguay?
Your answer should be very brief. 6.34e+09. In the year 2014, what is the difference between the Value added (constant 2005 US$) in Switzerland and Value added (constant 2005 US$) in Uruguay?
Keep it short and to the point. 3.23e+11. What is the ratio of the Value added (constant 2005 US$) in Switzerland in 2009 to that in 2010?
Your response must be concise. 0.98. What is the ratio of the Value added (constant 2005 US$) of Uruguay in 2009 to that in 2010?
Your answer should be very brief. 0.93. What is the ratio of the Value added (constant 2005 US$) in Euro area in 2009 to that in 2011?
Ensure brevity in your answer.  0.97. What is the ratio of the Value added (constant 2005 US$) in Guatemala in 2009 to that in 2011?
Make the answer very short. 0.92. What is the ratio of the Value added (constant 2005 US$) of Switzerland in 2009 to that in 2011?
Provide a short and direct response. 0.98. What is the ratio of the Value added (constant 2005 US$) in Uruguay in 2009 to that in 2011?
Your response must be concise. 0.88. What is the ratio of the Value added (constant 2005 US$) in Euro area in 2009 to that in 2012?
Give a very brief answer. 0.97. What is the ratio of the Value added (constant 2005 US$) of Guatemala in 2009 to that in 2012?
Offer a very short reply. 0.89. What is the ratio of the Value added (constant 2005 US$) of Switzerland in 2009 to that in 2012?
Your response must be concise. 0.96. What is the ratio of the Value added (constant 2005 US$) of Uruguay in 2009 to that in 2012?
Keep it short and to the point. 0.84. What is the ratio of the Value added (constant 2005 US$) of Euro area in 2009 to that in 2013?
Your answer should be very brief. 0.97. What is the ratio of the Value added (constant 2005 US$) of Guatemala in 2009 to that in 2013?
Provide a short and direct response. 0.86. What is the ratio of the Value added (constant 2005 US$) of Switzerland in 2009 to that in 2013?
Make the answer very short. 0.94. What is the ratio of the Value added (constant 2005 US$) of Uruguay in 2009 to that in 2013?
Offer a very short reply. 0.8. What is the ratio of the Value added (constant 2005 US$) in Euro area in 2009 to that in 2014?
Your answer should be very brief. 0.96. What is the ratio of the Value added (constant 2005 US$) of Guatemala in 2009 to that in 2014?
Keep it short and to the point. 0.83. What is the ratio of the Value added (constant 2005 US$) in Switzerland in 2009 to that in 2014?
Your answer should be very brief. 0.92. What is the ratio of the Value added (constant 2005 US$) of Uruguay in 2009 to that in 2014?
Your answer should be compact. 0.78. What is the ratio of the Value added (constant 2005 US$) of Guatemala in 2010 to that in 2011?
Ensure brevity in your answer.  0.96. What is the ratio of the Value added (constant 2005 US$) of Uruguay in 2010 to that in 2011?
Keep it short and to the point. 0.95. What is the ratio of the Value added (constant 2005 US$) in Euro area in 2010 to that in 2012?
Give a very brief answer. 0.98. What is the ratio of the Value added (constant 2005 US$) of Guatemala in 2010 to that in 2012?
Keep it short and to the point. 0.93. What is the ratio of the Value added (constant 2005 US$) in Switzerland in 2010 to that in 2012?
Ensure brevity in your answer.  0.98. What is the ratio of the Value added (constant 2005 US$) in Uruguay in 2010 to that in 2012?
Your answer should be very brief. 0.9. What is the ratio of the Value added (constant 2005 US$) of Euro area in 2010 to that in 2013?
Give a very brief answer. 0.98. What is the ratio of the Value added (constant 2005 US$) in Guatemala in 2010 to that in 2013?
Provide a succinct answer. 0.9. What is the ratio of the Value added (constant 2005 US$) of Switzerland in 2010 to that in 2013?
Make the answer very short. 0.96. What is the ratio of the Value added (constant 2005 US$) of Uruguay in 2010 to that in 2013?
Your answer should be very brief. 0.86. What is the ratio of the Value added (constant 2005 US$) of Euro area in 2010 to that in 2014?
Your answer should be compact. 0.97. What is the ratio of the Value added (constant 2005 US$) of Guatemala in 2010 to that in 2014?
Provide a short and direct response. 0.87. What is the ratio of the Value added (constant 2005 US$) in Switzerland in 2010 to that in 2014?
Provide a short and direct response. 0.94. What is the ratio of the Value added (constant 2005 US$) in Uruguay in 2010 to that in 2014?
Your answer should be very brief. 0.84. What is the ratio of the Value added (constant 2005 US$) of Euro area in 2011 to that in 2012?
Your answer should be compact. 1. What is the ratio of the Value added (constant 2005 US$) of Guatemala in 2011 to that in 2012?
Keep it short and to the point. 0.96. What is the ratio of the Value added (constant 2005 US$) in Switzerland in 2011 to that in 2012?
Provide a succinct answer. 0.98. What is the ratio of the Value added (constant 2005 US$) in Uruguay in 2011 to that in 2012?
Offer a very short reply. 0.95. What is the ratio of the Value added (constant 2005 US$) in Guatemala in 2011 to that in 2013?
Offer a very short reply. 0.93. What is the ratio of the Value added (constant 2005 US$) in Switzerland in 2011 to that in 2013?
Offer a terse response. 0.96. What is the ratio of the Value added (constant 2005 US$) in Uruguay in 2011 to that in 2013?
Offer a very short reply. 0.91. What is the ratio of the Value added (constant 2005 US$) of Euro area in 2011 to that in 2014?
Your answer should be compact. 0.99. What is the ratio of the Value added (constant 2005 US$) in Guatemala in 2011 to that in 2014?
Offer a terse response. 0.9. What is the ratio of the Value added (constant 2005 US$) of Switzerland in 2011 to that in 2014?
Make the answer very short. 0.94. What is the ratio of the Value added (constant 2005 US$) in Uruguay in 2011 to that in 2014?
Your answer should be very brief. 0.88. What is the ratio of the Value added (constant 2005 US$) in Euro area in 2012 to that in 2013?
Offer a very short reply. 1. What is the ratio of the Value added (constant 2005 US$) in Guatemala in 2012 to that in 2013?
Ensure brevity in your answer.  0.97. What is the ratio of the Value added (constant 2005 US$) in Switzerland in 2012 to that in 2013?
Your answer should be compact. 0.98. What is the ratio of the Value added (constant 2005 US$) in Uruguay in 2012 to that in 2013?
Ensure brevity in your answer.  0.95. What is the ratio of the Value added (constant 2005 US$) in Euro area in 2012 to that in 2014?
Offer a very short reply. 0.99. What is the ratio of the Value added (constant 2005 US$) of Guatemala in 2012 to that in 2014?
Provide a short and direct response. 0.93. What is the ratio of the Value added (constant 2005 US$) in Switzerland in 2012 to that in 2014?
Your answer should be very brief. 0.96. What is the ratio of the Value added (constant 2005 US$) in Uruguay in 2012 to that in 2014?
Offer a terse response. 0.93. What is the ratio of the Value added (constant 2005 US$) of Guatemala in 2013 to that in 2014?
Keep it short and to the point. 0.97. What is the ratio of the Value added (constant 2005 US$) in Switzerland in 2013 to that in 2014?
Make the answer very short. 0.98. What is the ratio of the Value added (constant 2005 US$) in Uruguay in 2013 to that in 2014?
Give a very brief answer. 0.97. What is the difference between the highest and the second highest Value added (constant 2005 US$) of Euro area?
Offer a terse response. 6.95e+1. What is the difference between the highest and the second highest Value added (constant 2005 US$) of Guatemala?
Your answer should be compact. 6.95e+08. What is the difference between the highest and the second highest Value added (constant 2005 US$) in Switzerland?
Give a very brief answer. 6.40e+09. What is the difference between the highest and the second highest Value added (constant 2005 US$) in Uruguay?
Make the answer very short. 4.60e+08. What is the difference between the highest and the lowest Value added (constant 2005 US$) in Euro area?
Make the answer very short. 2.83e+11. What is the difference between the highest and the lowest Value added (constant 2005 US$) in Guatemala?
Offer a terse response. 3.61e+09. What is the difference between the highest and the lowest Value added (constant 2005 US$) in Switzerland?
Offer a very short reply. 2.67e+1. What is the difference between the highest and the lowest Value added (constant 2005 US$) in Uruguay?
Your answer should be very brief. 3.37e+09. 